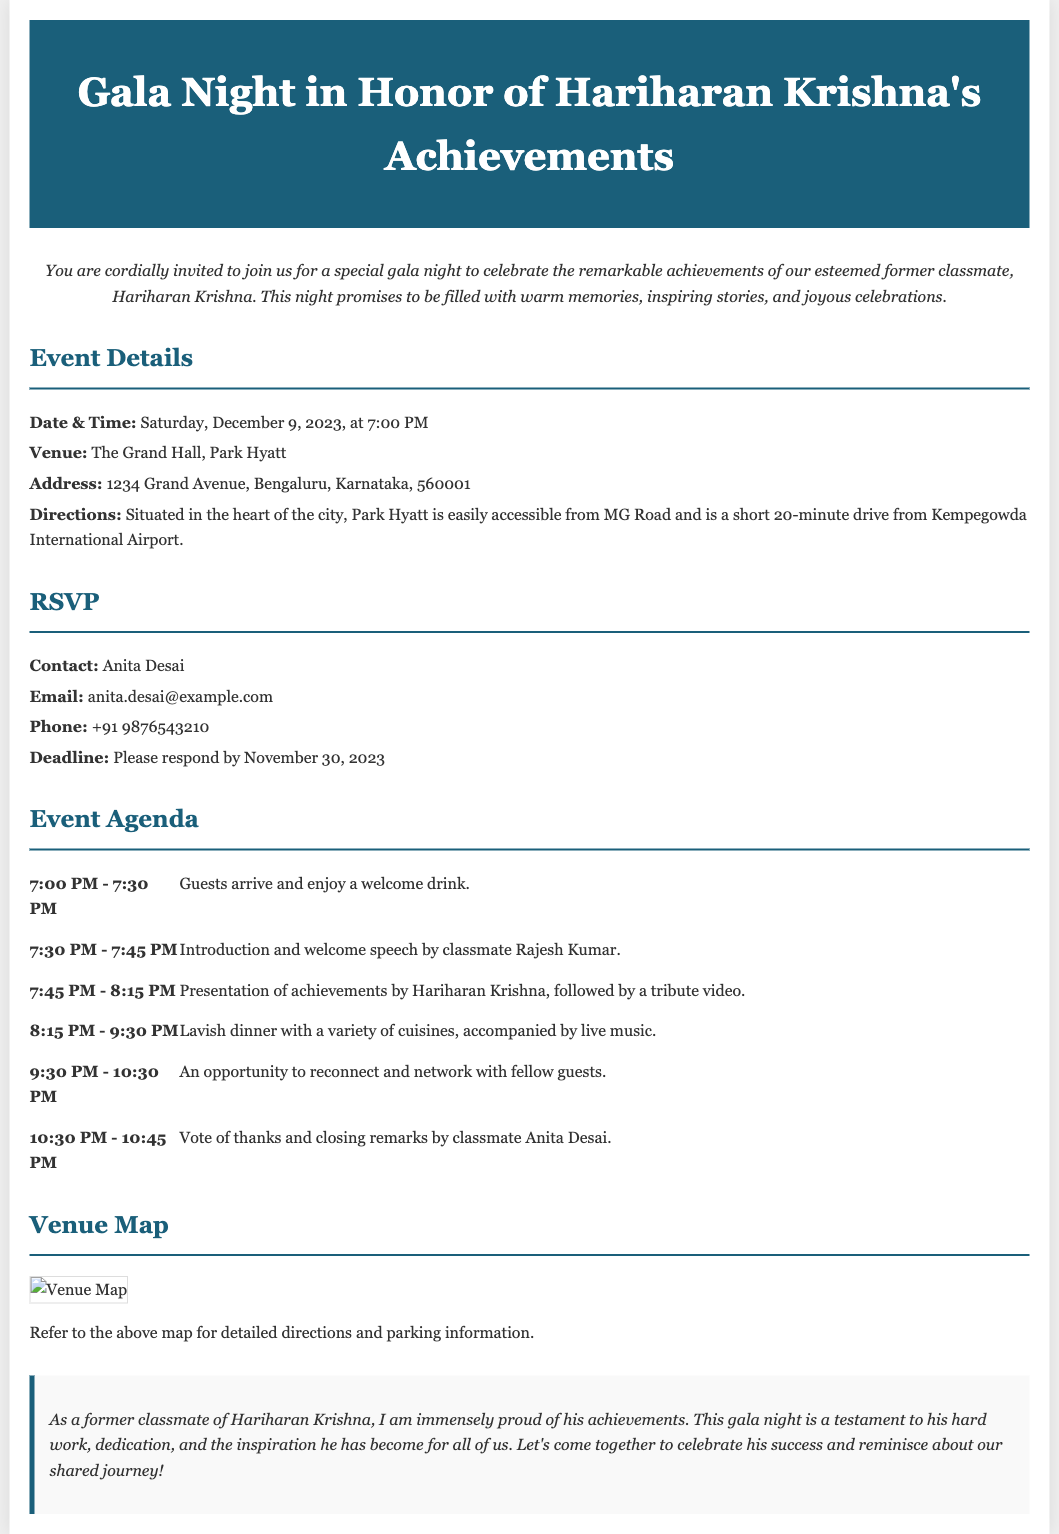What is the date of the event? The date of the event is specifically mentioned in the event details section, which states it is on Saturday, December 9, 2023.
Answer: December 9, 2023 Who is the main honoree of the gala night? The document highlights Hariharan Krishna as the main honoree of the gala night, celebrating his achievements.
Answer: Hariharan Krishna What time does the dinner start? According to the event agenda, the lavish dinner starts at 8:15 PM.
Answer: 8:15 PM What is the RSVP deadline? The RSVP section clearly states that the deadline for responses is November 30, 2023.
Answer: November 30, 2023 What will happen at 7:30 PM during the event? The agenda indicates that at 7:30 PM, there is an introduction and welcome speech by classmate Rajesh Kumar.
Answer: Introduction and welcome speech by Rajesh Kumar Where is the venue located? The event details section provides a specific address, listing the venue as The Grand Hall, Park Hyatt, with the address located at 1234 Grand Avenue, Bengaluru.
Answer: The Grand Hall, Park Hyatt How long is the live music segment scheduled to last? The agenda does not explicitly state the live music segment but suggests it runs during the lavish dinner time, which is from 8:15 PM to 9:30 PM. Thus, it lasts for 1 hour and 15 minutes.
Answer: 1 hour and 15 minutes What is the contact email for RSVP? The RSVP section mentions a specific email for contact, which is anita.desai@example.com.
Answer: anita.desai@example.com 